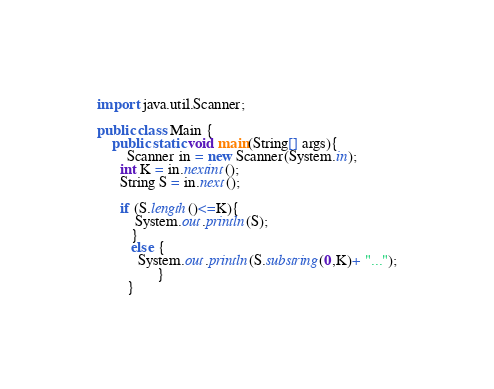Convert code to text. <code><loc_0><loc_0><loc_500><loc_500><_Java_>import java.util.Scanner;
 
public class Main {
    public static void main(String[] args){
        Scanner in = new Scanner(System.in);
      int K = in.nextint();  
      String S = in.next();
      
      if (S.length()<=K){
          System.out.println(S);
         }
         else {
           System.out.println(S.substring(0,K)+ "...");
                }
        }</code> 